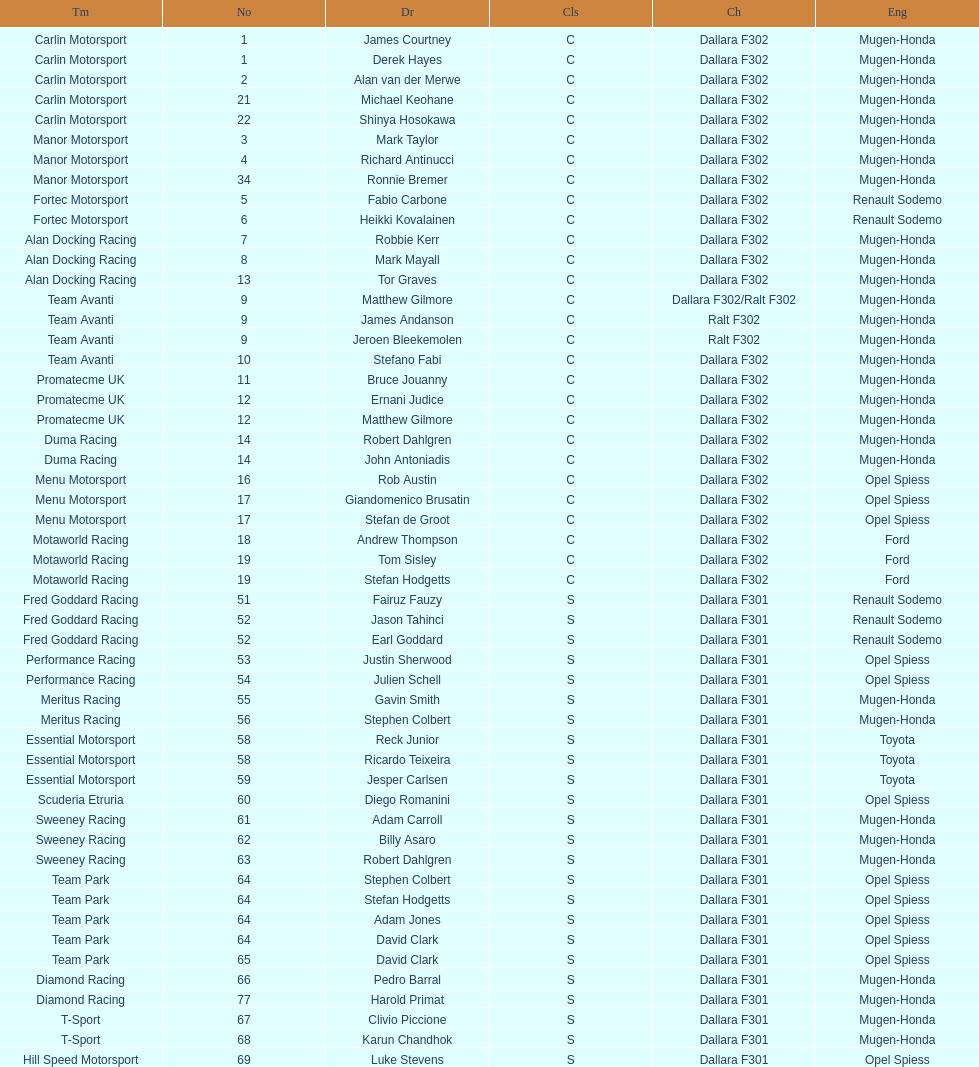The two drivers on t-sport are clivio piccione and what other driver? Karun Chandhok. 